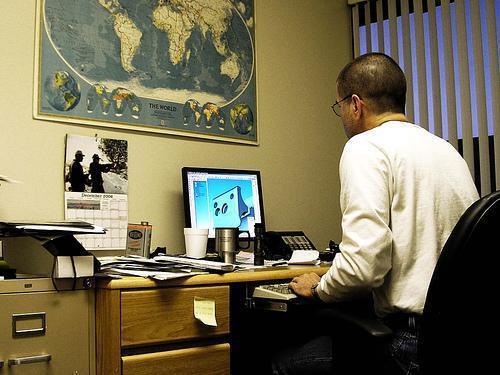How many people are there?
Give a very brief answer. 1. 